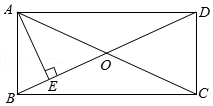How can we prove that triangle AED is a right triangle? To prove that triangle AED is a right triangle, observe that line AE is perpendicular to diagonal BD at point E by definition. The right angle at vertex E verifies that triangle AED is indeed a right triangle. Additionally, knowing diagonal BD is bisected by diagonal AC at point O adds an element of geometric significance in dissecting further properties. 